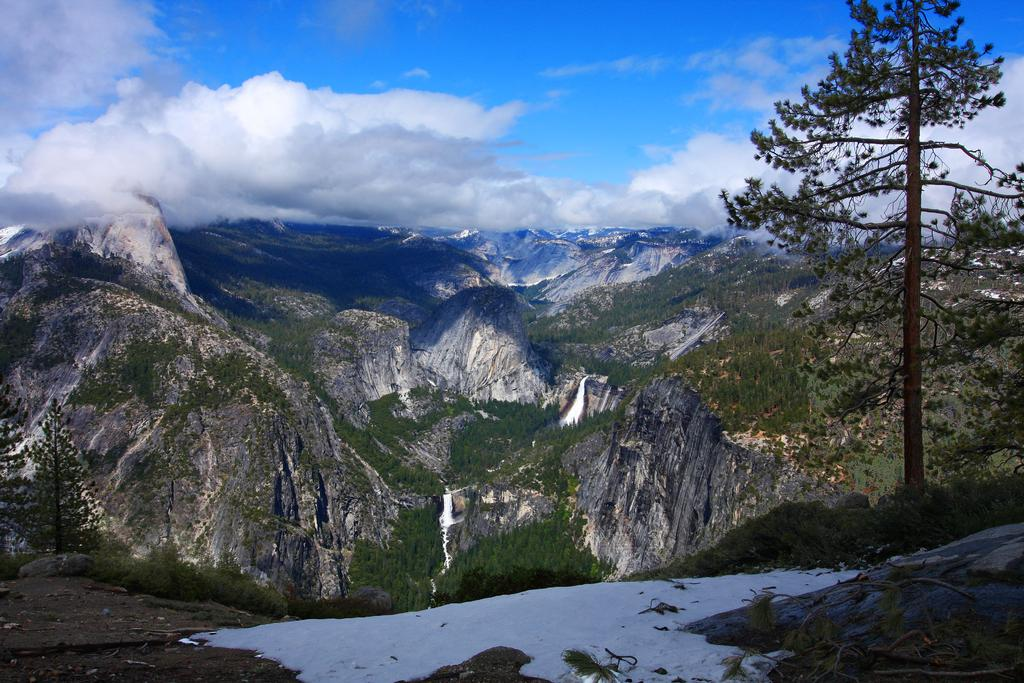What is the condition of the sky in the image? The sky is cloudy in the image. What can be seen on the mountain in the image? There are trees on the mountain in the image. What type of weather is suggested by the presence of snow in the image? The presence of snow suggests cold weather in the image. What type of clam can be seen crawling on the mountain in the image? There are no clams present in the image, as it features a mountain with trees and snow. What grade is the cub in the image? There is no cub or any indication of a school setting in the image. 